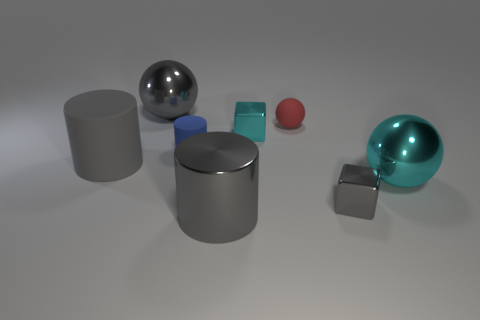Add 1 shiny cylinders. How many objects exist? 9 Subtract all brown blocks. Subtract all cyan cylinders. How many blocks are left? 2 Subtract all cylinders. How many objects are left? 5 Add 5 tiny rubber things. How many tiny rubber things are left? 7 Add 5 gray rubber cylinders. How many gray rubber cylinders exist? 6 Subtract 0 red cubes. How many objects are left? 8 Subtract all metallic balls. Subtract all blue things. How many objects are left? 5 